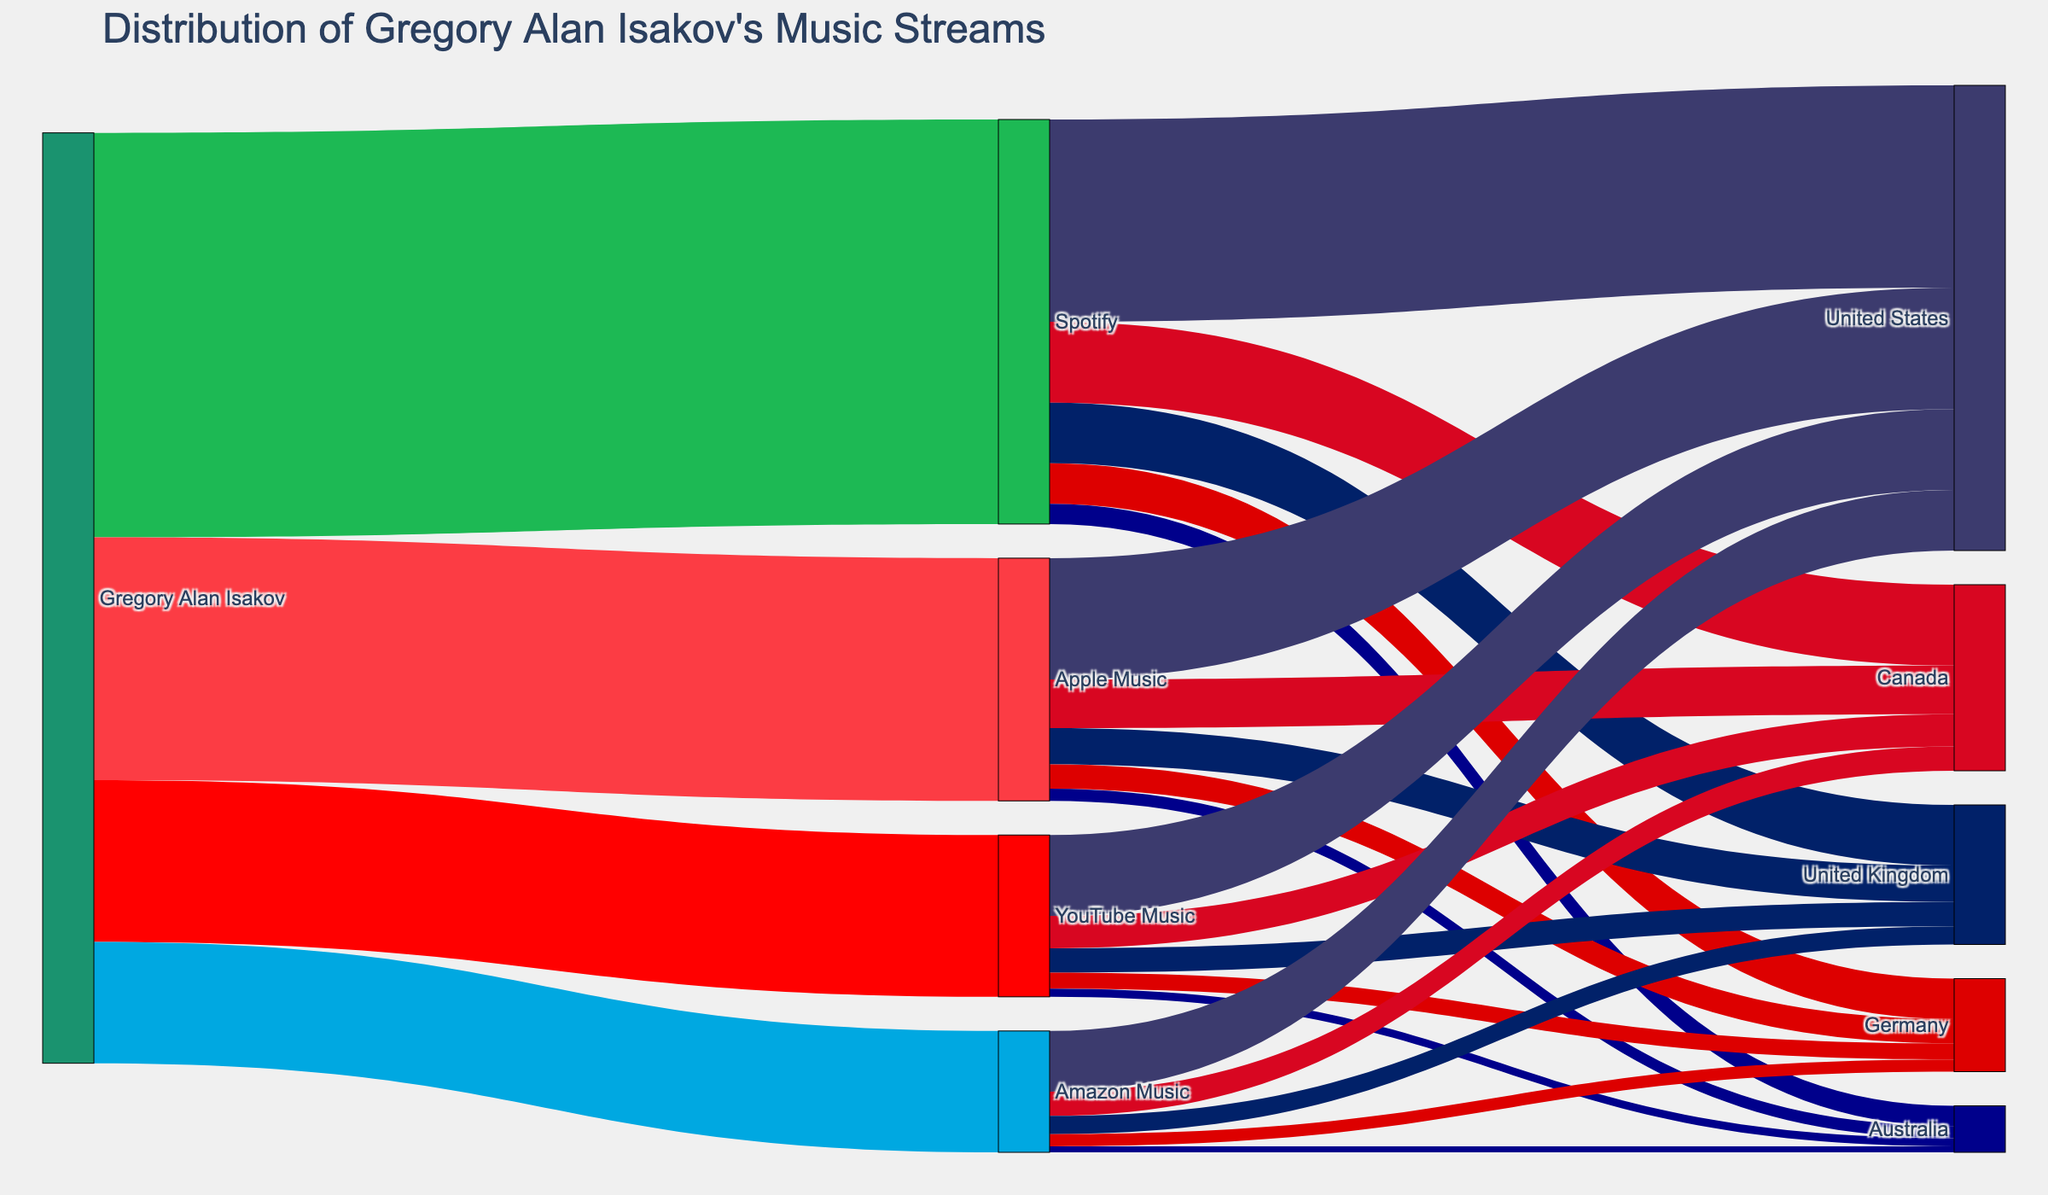what is the total number of streams from Gregory Alan Isakov through Spotify? Starting from Gregory Alan Isakov, follow the link to Spotify. The value is 500,000 streams.
Answer: 500,000 How many countries are involved in streaming Gregory Alan Isakov's music via YouTube Music? Follow the link from YouTube Music to its connected countries. There are five countries: United States, Canada, United Kingdom, Germany, and Australia.
Answer: 5 What is the difference in the number of streams between the United States and Canada on Apple Music? Look at the values for the United States and Canada under Apple Music. The United States has 150,000 streams, and Canada has 60,000 streams. The difference is 150,000 - 60,000 = 90,000.
Answer: 90,000 Which platform has the smallest number of streams for Gregory Alan Isakov’s music? Follow the links from Gregory Alan Isakov to all platforms: Spotify (500,000), Apple Music (300,000), YouTube Music (200,000), Amazon Music (150,000). Amazon Music has the smallest number with 150,000 streams.
Answer: Amazon Music For Gregory Alan Isakov’s streams on Spotify, what is the sum of streams from United Kingdom and Australia? Follow the links from Spotify to United Kingdom (75,000) and Australia (25,000). The sum is 75,000 + 25,000 = 100,000.
Answer: 100,000 What is the combined number of streams from Germany across all platforms? Follow the links from all platforms to Germany: Spotify (50,000), Apple Music (30,000), YouTube Music (20,000), Amazon Music (15,000). The combined number is 50,000 + 30,000 + 20,000 + 15,000 = 115,000.
Answer: 115,000 Which country receives the largest number of total streams for Gregory Alan Isakov’s music from all platforms? Sum up the streams for each country: United States, Canada, United Kingdom, Germany, and Australia across all platforms and compare the totals. The United States has the highest number with: Spotify (250,000) + Apple Music (150,000) + YouTube Music (100,000) + Amazon Music (75,000) = 575,000.
Answer: United States What percentage of YouTube Music’s total streams come from the United States? Identify the total number of streams on YouTube Music (200,000) and the number from the United States (100,000). The percentage is (100,000 / 200,000) * 100% = 50%.
Answer: 50% Through which platform does Gregory Alan Isakov receive more streams from Germany, Apple Music, or YouTube Music? Follow the links to Germany from both Apple Music (30,000) and YouTube Music (20,000). Apple Music has more streams.
Answer: Apple Music 